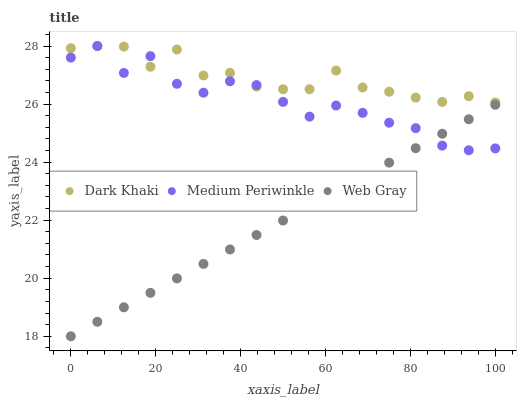Does Web Gray have the minimum area under the curve?
Answer yes or no. Yes. Does Dark Khaki have the maximum area under the curve?
Answer yes or no. Yes. Does Medium Periwinkle have the minimum area under the curve?
Answer yes or no. No. Does Medium Periwinkle have the maximum area under the curve?
Answer yes or no. No. Is Web Gray the smoothest?
Answer yes or no. Yes. Is Medium Periwinkle the roughest?
Answer yes or no. Yes. Is Medium Periwinkle the smoothest?
Answer yes or no. No. Is Web Gray the roughest?
Answer yes or no. No. Does Web Gray have the lowest value?
Answer yes or no. Yes. Does Medium Periwinkle have the lowest value?
Answer yes or no. No. Does Medium Periwinkle have the highest value?
Answer yes or no. Yes. Does Web Gray have the highest value?
Answer yes or no. No. Is Web Gray less than Dark Khaki?
Answer yes or no. Yes. Is Dark Khaki greater than Web Gray?
Answer yes or no. Yes. Does Web Gray intersect Medium Periwinkle?
Answer yes or no. Yes. Is Web Gray less than Medium Periwinkle?
Answer yes or no. No. Is Web Gray greater than Medium Periwinkle?
Answer yes or no. No. Does Web Gray intersect Dark Khaki?
Answer yes or no. No. 